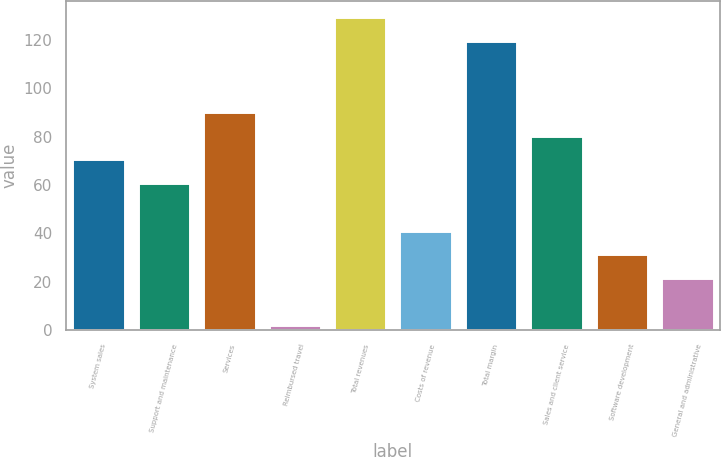<chart> <loc_0><loc_0><loc_500><loc_500><bar_chart><fcel>System sales<fcel>Support and maintenance<fcel>Services<fcel>Reimbursed travel<fcel>Total revenues<fcel>Costs of revenue<fcel>Total margin<fcel>Sales and client service<fcel>Software development<fcel>General and administrative<nl><fcel>70.6<fcel>60.8<fcel>90.2<fcel>2<fcel>129.4<fcel>41.2<fcel>119.6<fcel>80.4<fcel>31.4<fcel>21.6<nl></chart> 